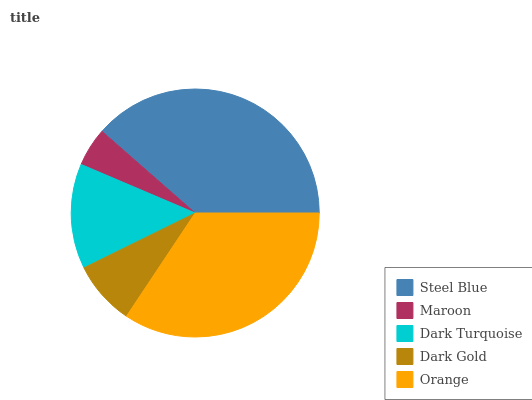Is Maroon the minimum?
Answer yes or no. Yes. Is Steel Blue the maximum?
Answer yes or no. Yes. Is Dark Turquoise the minimum?
Answer yes or no. No. Is Dark Turquoise the maximum?
Answer yes or no. No. Is Dark Turquoise greater than Maroon?
Answer yes or no. Yes. Is Maroon less than Dark Turquoise?
Answer yes or no. Yes. Is Maroon greater than Dark Turquoise?
Answer yes or no. No. Is Dark Turquoise less than Maroon?
Answer yes or no. No. Is Dark Turquoise the high median?
Answer yes or no. Yes. Is Dark Turquoise the low median?
Answer yes or no. Yes. Is Orange the high median?
Answer yes or no. No. Is Orange the low median?
Answer yes or no. No. 